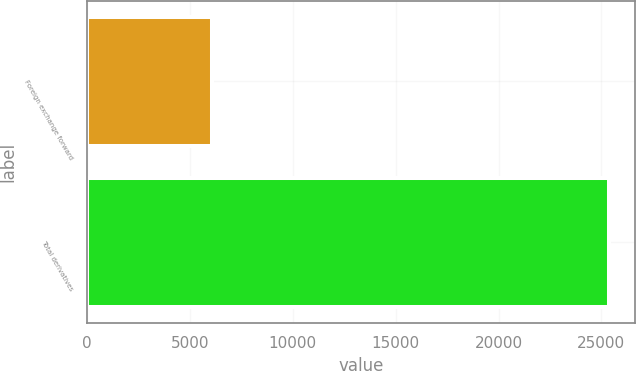Convert chart to OTSL. <chart><loc_0><loc_0><loc_500><loc_500><bar_chart><fcel>Foreign exchange forward<fcel>Total derivatives<nl><fcel>6066<fcel>25362<nl></chart> 